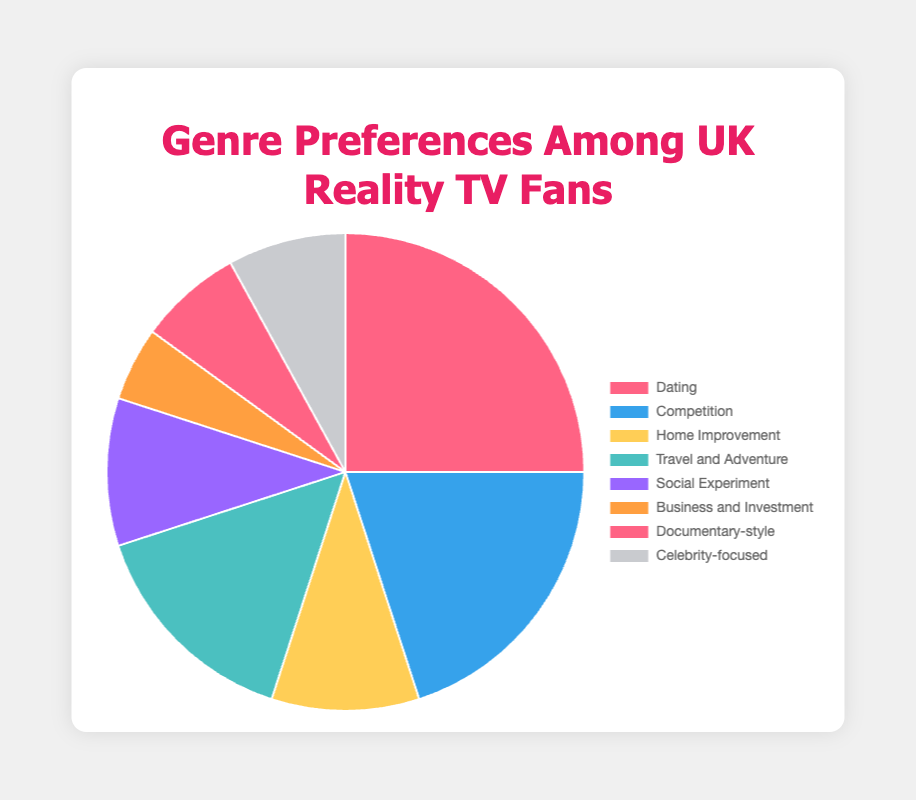What's the most preferred genre among UK reality TV fans? The pie chart shows different genres with their respective percentages. The genre with the highest percentage is the most preferred.
Answer: Dating Which genre has a higher preference: Home Improvement or Celebrity-focused? Compare the percentages of Home Improvement (10%) and Celebrity-focused (8%). Home Improvement has a higher percentage.
Answer: Home Improvement What is the total percentage for the genres related to adventure and travel combined with social experiments? Add the percentages for Travel and Adventure (15%) and Social Experiment (10%). 15% + 10% = 25%.
Answer: 25% How many genres have a preference percentage of 10% or higher? Identify and count genres with 10% or more. The genres are Dating (25%), Competition (20%), Travel and Adventure (15%), Home Improvement (10%), and Social Experiment (10%). A total of 5 genres fit this criterion.
Answer: 5 Which genre holds the smallest share of preferences among UK reality TV fans? The genre with the smallest percentage in the pie chart is the least preferred.
Answer: Business and Investment By how much does the preference for Dating exceed that for Business and Investment? Subtract the percentage of Business and Investment (5%) from Dating (25%). 25% - 5% = 20%.
Answer: 20% Are the combined preferences for Documentary-style and Celebrity-focused greater than the preference for Travel and Adventure? Add the percentages for Documentary-style (7%) and Celebrity-focused (8%). 7% + 8% = 15%. The combined total (15%) is equal to Travel and Adventure (15%).
Answer: No Rank the top three genres by preference percentage. List the top three genres in descending order of their percentages: Dating (25%), Competition (20%), Travel and Adventure (15%).
Answer: Dating, Competition, Travel and Adventure Which genres have the same preference percentage? Identify the genres with matching percentages: Home Improvement (10%) and Social Experiment (10%).
Answer: Home Improvement and Social Experiment What is the average preference percentage for the genres Competition, Business and Investment, and Documentary-style? Add the percentages for Competition (20%), Business and Investment (5%), and Documentary-style (7%). Divide by the number of genres (3). (20% + 5% + 7%) / 3 = 10.67%.
Answer: 10.67% 